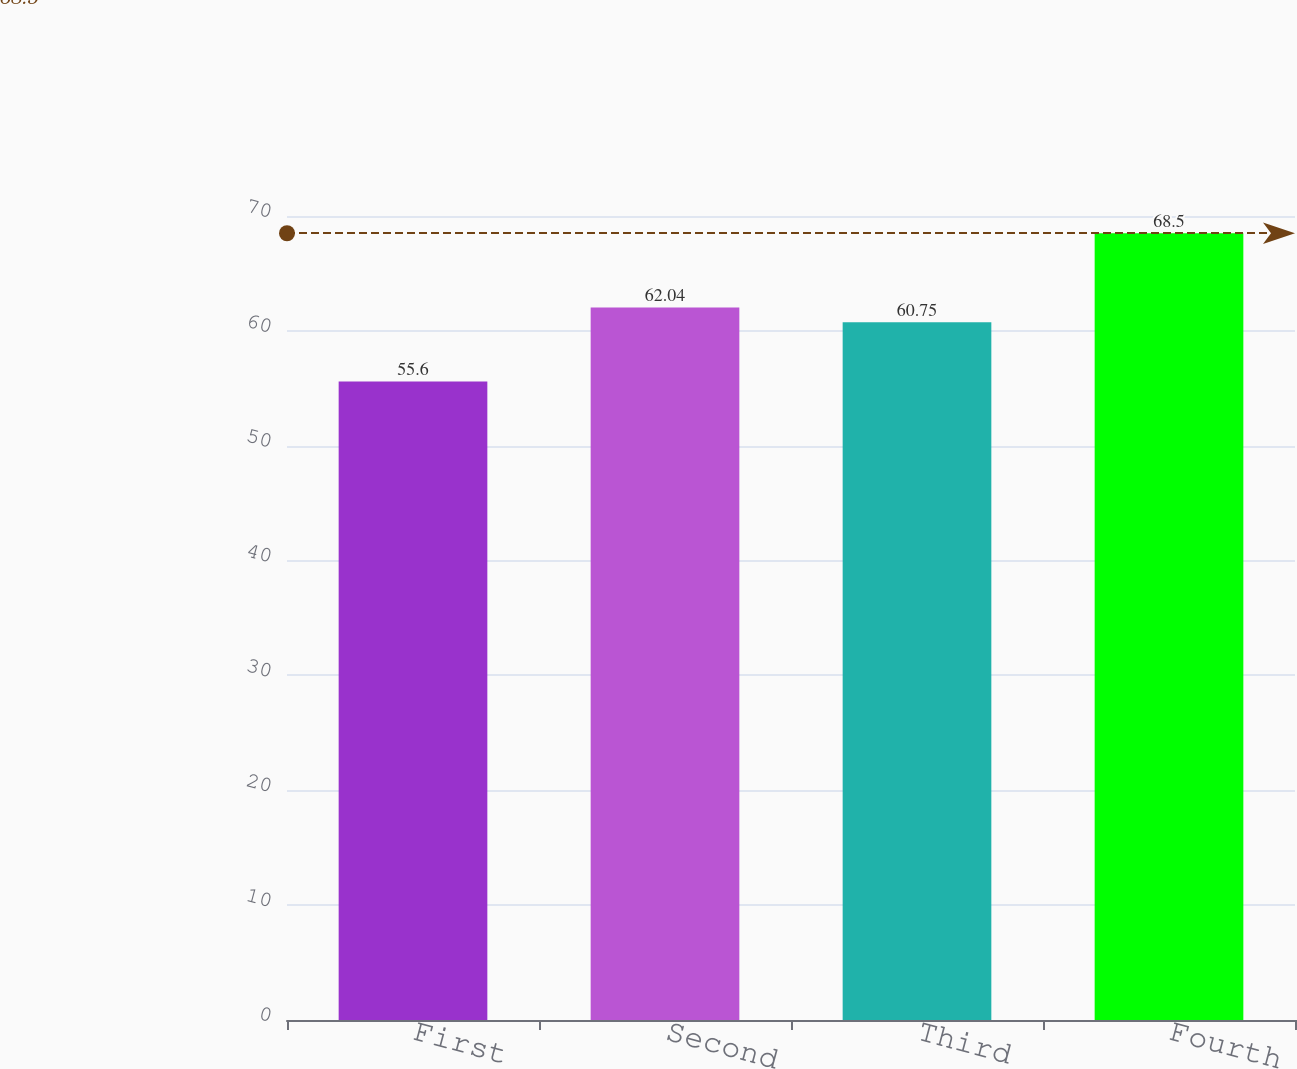Convert chart to OTSL. <chart><loc_0><loc_0><loc_500><loc_500><bar_chart><fcel>First<fcel>Second<fcel>Third<fcel>Fourth<nl><fcel>55.6<fcel>62.04<fcel>60.75<fcel>68.5<nl></chart> 